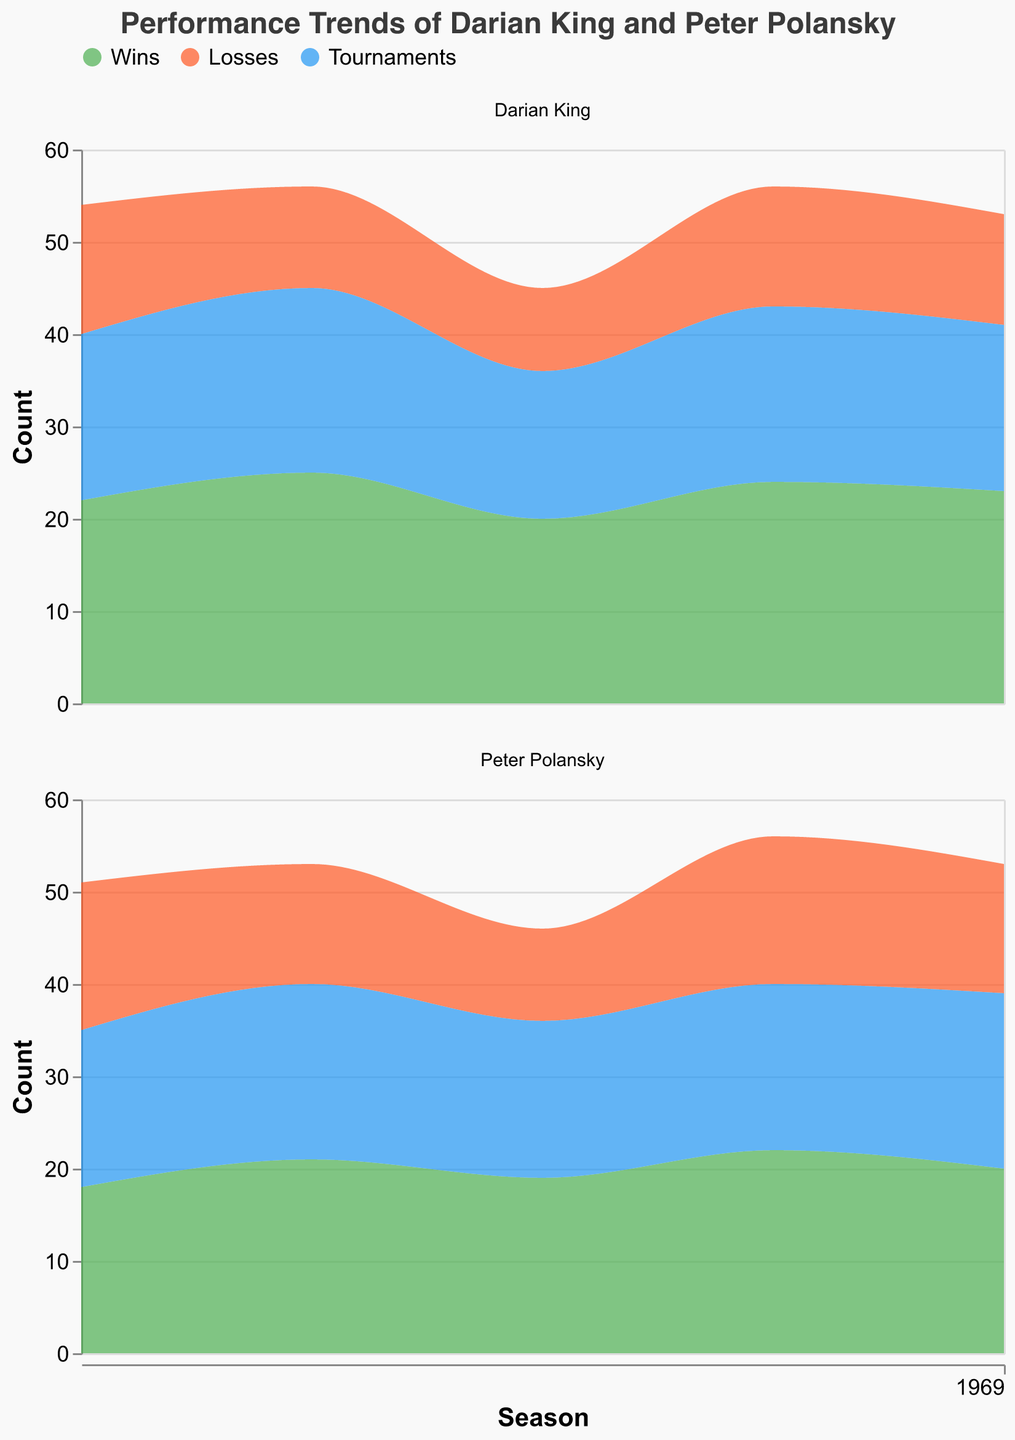Which player had more wins in 2022? Look at the value for wins in 2022 for both players. Darian King had 23 wins while Peter Polansky had 20 wins.
Answer: Darian King What is the trend in the number of tournaments Darian King participated in from 2018 to 2022? Observe the trend in the value of tournaments for Darian King across the years. The values are 18, 20, 16, 19, and 18. The number fluctuates but tends to stabilize around 18-20.
Answer: Fluctuates, stabilizing around 18-20 Who had fewer losses in 2020? Compare the number of losses in 2020 for both players. Darian King had 9 losses while Peter Polansky had 10 losses.
Answer: Darian King In which year did Peter Polansky have the highest number of wins? Look at the number of wins for Peter Polansky across all years. The values are 18, 21, 19, 22, and 20. The highest is 22 which occurred in 2021.
Answer: 2021 What is the total number of tournaments both players participated in during 2019? Add the number of tournaments for both players in 2019. Darian King participated in 20 tournaments and Peter Polansky in 19 tournaments. The total is 20 + 19 = 39.
Answer: 39 How did the number of wins for Darian King change from 2018 to 2019? Compare the number of wins for Darian King in 2018 and 2019. The values are 22 wins in 2018 and 25 wins in 2019. The wins increased by 3.
Answer: Increased by 3 Which player had a lower win-to-loss ratio in 2021? Calculate the win-to-loss ratio for each player in 2021: 
Darian King: 24 wins / 13 losses ≈ 1.85
Peter Polansky: 22 wins / 16 losses ≈ 1.38
Peter Polansky had a lower win-to-loss ratio.
Answer: Peter Polansky In what year did Darian King have the fewest losses? Look at the losses for Darian King in each year: 14, 11, 9, 13, and 12. The fewest losses were 9 in 2020.
Answer: 2020 How does the number of tournaments for Peter Polansky in 2018 compare to 2022? Compare the number of tournaments Peter Polansky participated in for 2018 and 2022. The values are 17 tournaments in 2018 and 19 tournaments in 2022. The number increased by 2.
Answer: Increased by 2 